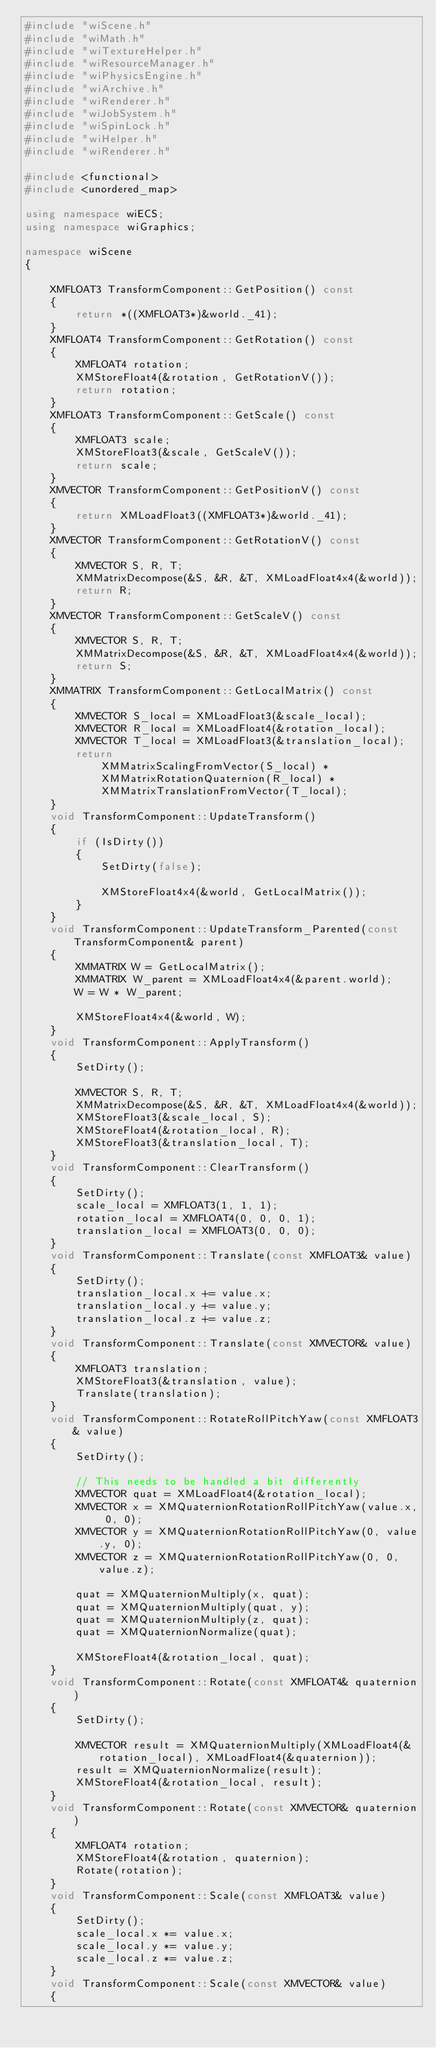<code> <loc_0><loc_0><loc_500><loc_500><_C++_>#include "wiScene.h"
#include "wiMath.h"
#include "wiTextureHelper.h"
#include "wiResourceManager.h"
#include "wiPhysicsEngine.h"
#include "wiArchive.h"
#include "wiRenderer.h"
#include "wiJobSystem.h"
#include "wiSpinLock.h"
#include "wiHelper.h"
#include "wiRenderer.h"

#include <functional>
#include <unordered_map>

using namespace wiECS;
using namespace wiGraphics;

namespace wiScene
{

	XMFLOAT3 TransformComponent::GetPosition() const
	{
		return *((XMFLOAT3*)&world._41);
	}
	XMFLOAT4 TransformComponent::GetRotation() const
	{
		XMFLOAT4 rotation;
		XMStoreFloat4(&rotation, GetRotationV());
		return rotation;
	}
	XMFLOAT3 TransformComponent::GetScale() const
	{
		XMFLOAT3 scale;
		XMStoreFloat3(&scale, GetScaleV());
		return scale;
	}
	XMVECTOR TransformComponent::GetPositionV() const
	{
		return XMLoadFloat3((XMFLOAT3*)&world._41);
	}
	XMVECTOR TransformComponent::GetRotationV() const
	{
		XMVECTOR S, R, T;
		XMMatrixDecompose(&S, &R, &T, XMLoadFloat4x4(&world));
		return R;
	}
	XMVECTOR TransformComponent::GetScaleV() const
	{
		XMVECTOR S, R, T;
		XMMatrixDecompose(&S, &R, &T, XMLoadFloat4x4(&world));
		return S;
	}
	XMMATRIX TransformComponent::GetLocalMatrix() const
	{
		XMVECTOR S_local = XMLoadFloat3(&scale_local);
		XMVECTOR R_local = XMLoadFloat4(&rotation_local);
		XMVECTOR T_local = XMLoadFloat3(&translation_local);
		return
			XMMatrixScalingFromVector(S_local) *
			XMMatrixRotationQuaternion(R_local) *
			XMMatrixTranslationFromVector(T_local);
	}
	void TransformComponent::UpdateTransform()
	{
		if (IsDirty())
		{
			SetDirty(false);

			XMStoreFloat4x4(&world, GetLocalMatrix());
		}
	}
	void TransformComponent::UpdateTransform_Parented(const TransformComponent& parent)
	{
		XMMATRIX W = GetLocalMatrix();
		XMMATRIX W_parent = XMLoadFloat4x4(&parent.world);
		W = W * W_parent;

		XMStoreFloat4x4(&world, W);
	}
	void TransformComponent::ApplyTransform()
	{
		SetDirty();

		XMVECTOR S, R, T;
		XMMatrixDecompose(&S, &R, &T, XMLoadFloat4x4(&world));
		XMStoreFloat3(&scale_local, S);
		XMStoreFloat4(&rotation_local, R);
		XMStoreFloat3(&translation_local, T);
	}
	void TransformComponent::ClearTransform()
	{
		SetDirty();
		scale_local = XMFLOAT3(1, 1, 1);
		rotation_local = XMFLOAT4(0, 0, 0, 1);
		translation_local = XMFLOAT3(0, 0, 0);
	}
	void TransformComponent::Translate(const XMFLOAT3& value)
	{
		SetDirty();
		translation_local.x += value.x;
		translation_local.y += value.y;
		translation_local.z += value.z;
	}
	void TransformComponent::Translate(const XMVECTOR& value)
	{
		XMFLOAT3 translation;
		XMStoreFloat3(&translation, value);
		Translate(translation);
	}
	void TransformComponent::RotateRollPitchYaw(const XMFLOAT3& value)
	{
		SetDirty();

		// This needs to be handled a bit differently
		XMVECTOR quat = XMLoadFloat4(&rotation_local);
		XMVECTOR x = XMQuaternionRotationRollPitchYaw(value.x, 0, 0);
		XMVECTOR y = XMQuaternionRotationRollPitchYaw(0, value.y, 0);
		XMVECTOR z = XMQuaternionRotationRollPitchYaw(0, 0, value.z);

		quat = XMQuaternionMultiply(x, quat);
		quat = XMQuaternionMultiply(quat, y);
		quat = XMQuaternionMultiply(z, quat);
		quat = XMQuaternionNormalize(quat);

		XMStoreFloat4(&rotation_local, quat);
	}
	void TransformComponent::Rotate(const XMFLOAT4& quaternion)
	{
		SetDirty();

		XMVECTOR result = XMQuaternionMultiply(XMLoadFloat4(&rotation_local), XMLoadFloat4(&quaternion));
		result = XMQuaternionNormalize(result);
		XMStoreFloat4(&rotation_local, result);
	}
	void TransformComponent::Rotate(const XMVECTOR& quaternion)
	{
		XMFLOAT4 rotation;
		XMStoreFloat4(&rotation, quaternion);
		Rotate(rotation);
	}
	void TransformComponent::Scale(const XMFLOAT3& value)
	{
		SetDirty();
		scale_local.x *= value.x;
		scale_local.y *= value.y;
		scale_local.z *= value.z;
	}
	void TransformComponent::Scale(const XMVECTOR& value)
	{</code> 